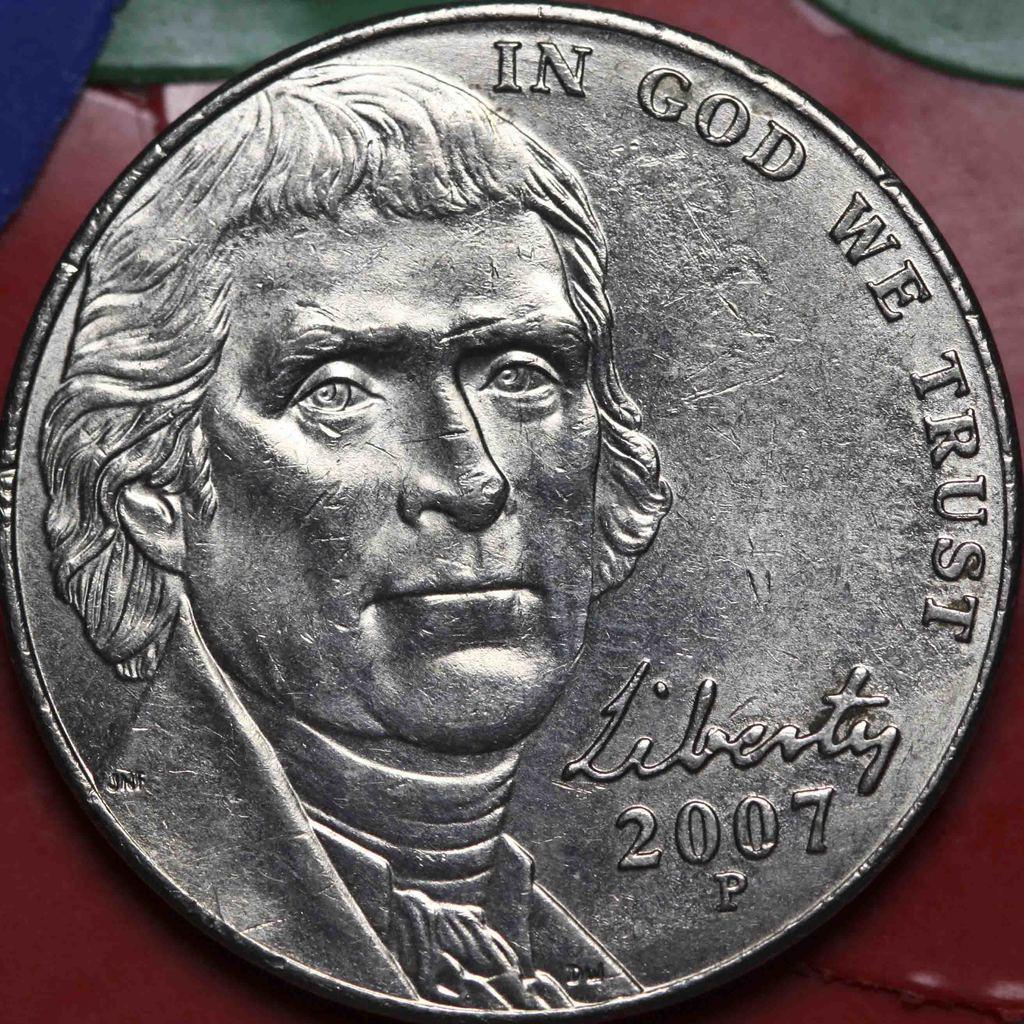How would you summarize this image in a sentence or two? In this image I can see a silver coin. I can also see a person's face and something written on the coin. 